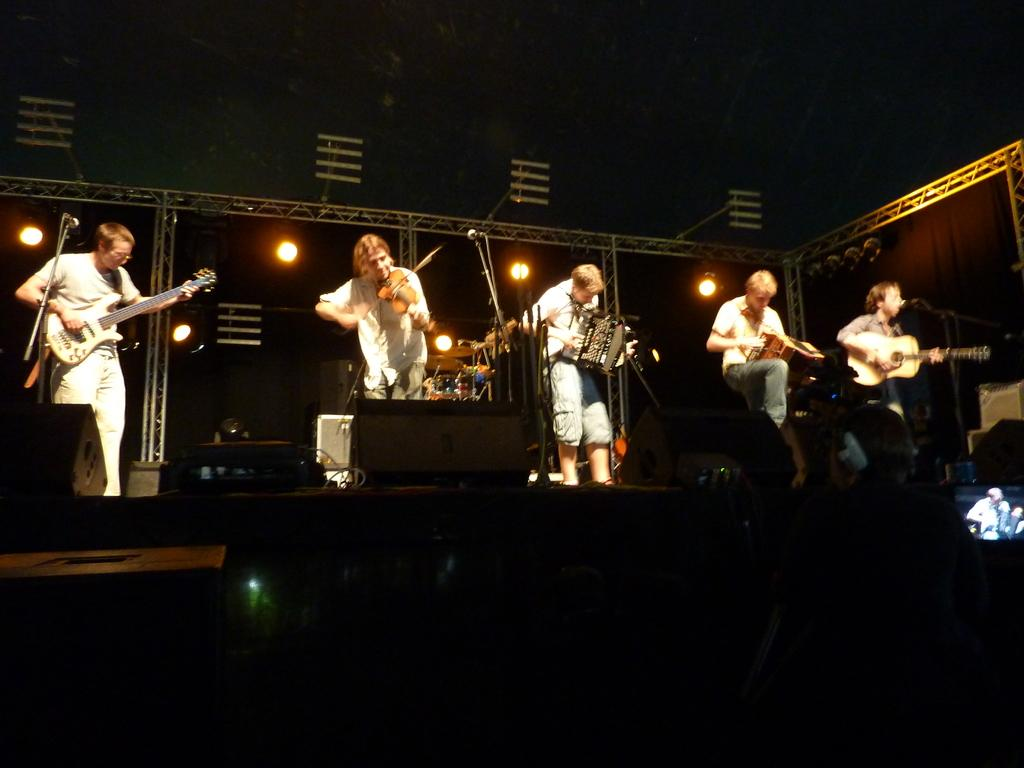What can be seen at the top of the image? There are lights visible at the top of the image. What are the men in the image doing? The men are standing in front of microphones and playing musical instruments on a platform. What is located on the right side of the image? There is a screen on the right side of the image. What type of seed is being planted on the screen in the image? There is no seed or planting activity depicted on the screen in the image. How does the celery contribute to the performance of the men in the image? There is no celery present in the image, and it does not contribute to the performance of the men. 